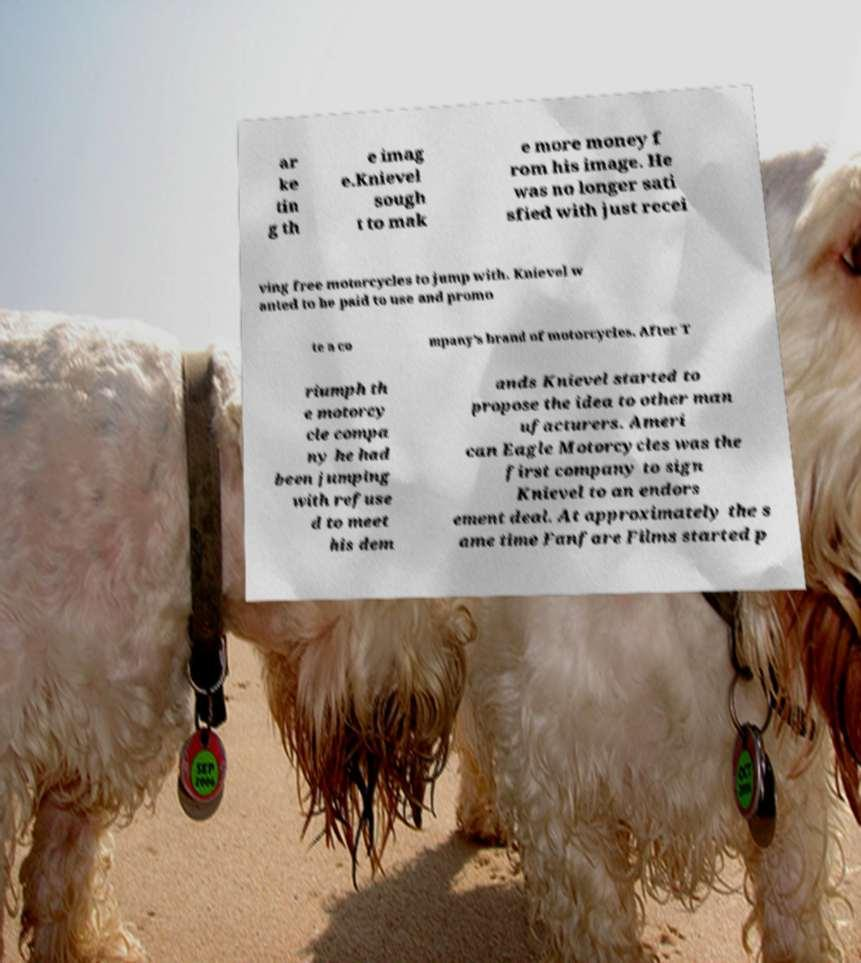There's text embedded in this image that I need extracted. Can you transcribe it verbatim? ar ke tin g th e imag e.Knievel sough t to mak e more money f rom his image. He was no longer sati sfied with just recei ving free motorcycles to jump with. Knievel w anted to be paid to use and promo te a co mpany's brand of motorcycles. After T riumph th e motorcy cle compa ny he had been jumping with refuse d to meet his dem ands Knievel started to propose the idea to other man ufacturers. Ameri can Eagle Motorcycles was the first company to sign Knievel to an endors ement deal. At approximately the s ame time Fanfare Films started p 